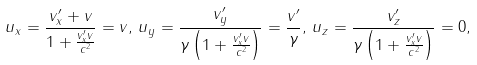<formula> <loc_0><loc_0><loc_500><loc_500>u _ { x } = \frac { v ^ { \prime } _ { x } + v } { 1 + \frac { v ^ { \prime } _ { x } v } { c ^ { 2 } } } = v , \, u _ { y } = \frac { v ^ { \prime } _ { y } } { \gamma \left ( 1 + \frac { v ^ { \prime } _ { x } v } { c ^ { 2 } } \right ) } = \frac { v ^ { \prime } } { \gamma } , \, u _ { z } = \frac { v ^ { \prime } _ { z } } { \gamma \left ( 1 + \frac { v ^ { \prime } _ { x } v } { c ^ { 2 } } \right ) } = 0 ,</formula> 